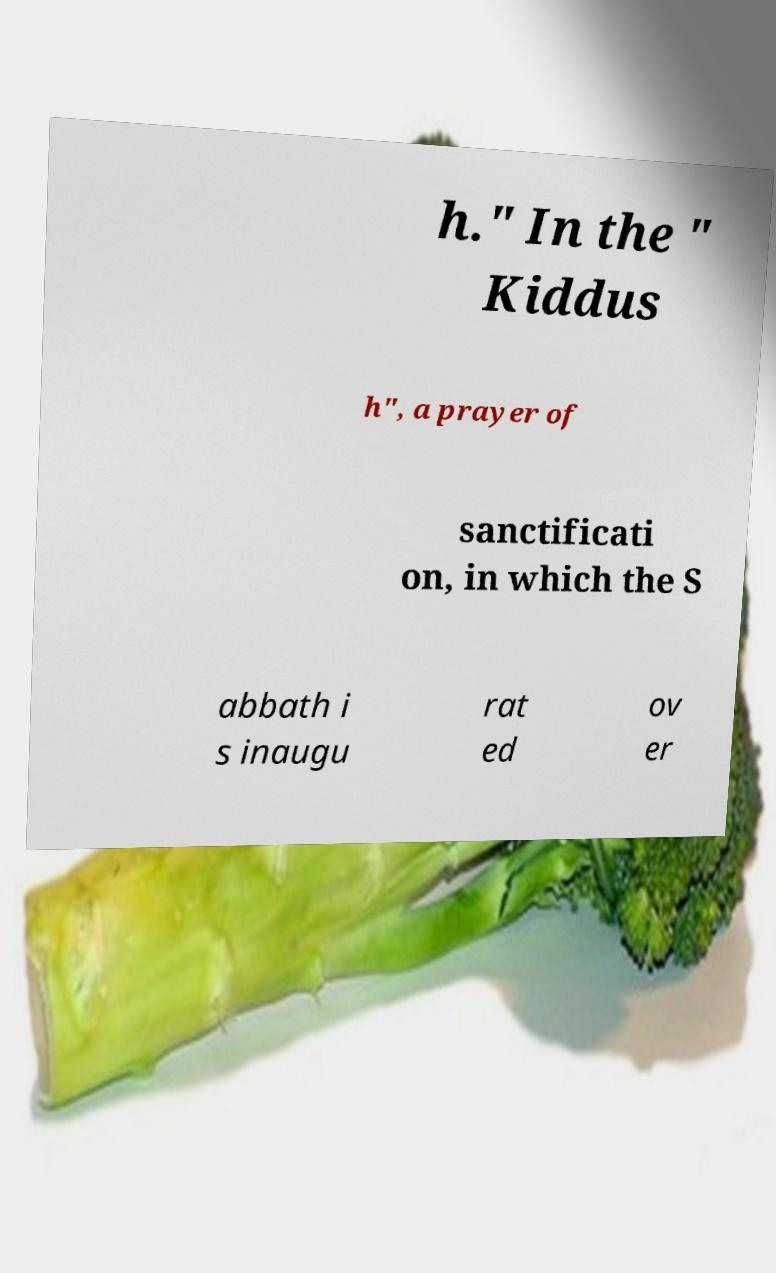Could you extract and type out the text from this image? h." In the " Kiddus h", a prayer of sanctificati on, in which the S abbath i s inaugu rat ed ov er 